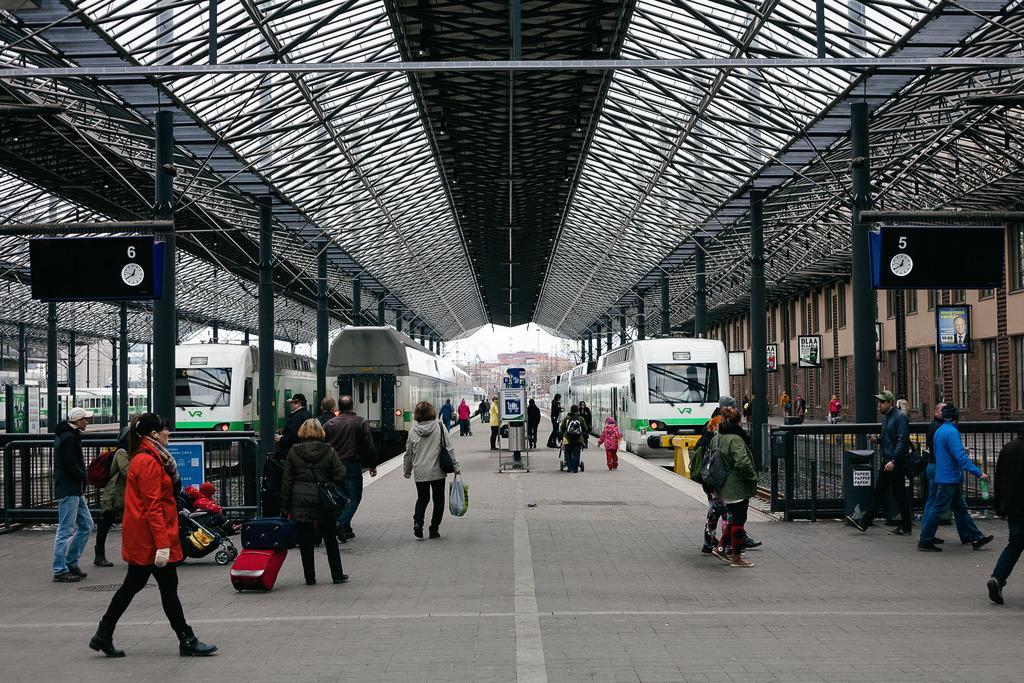Describe this image in one or two sentences. In the center of the image there are people walking on the road. There are trains. At the top of the image there are rods. There are railings. 